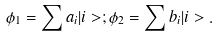Convert formula to latex. <formula><loc_0><loc_0><loc_500><loc_500>\phi _ { 1 } = \sum a _ { i } | i > ; \phi _ { 2 } = \sum b _ { i } | i > .</formula> 